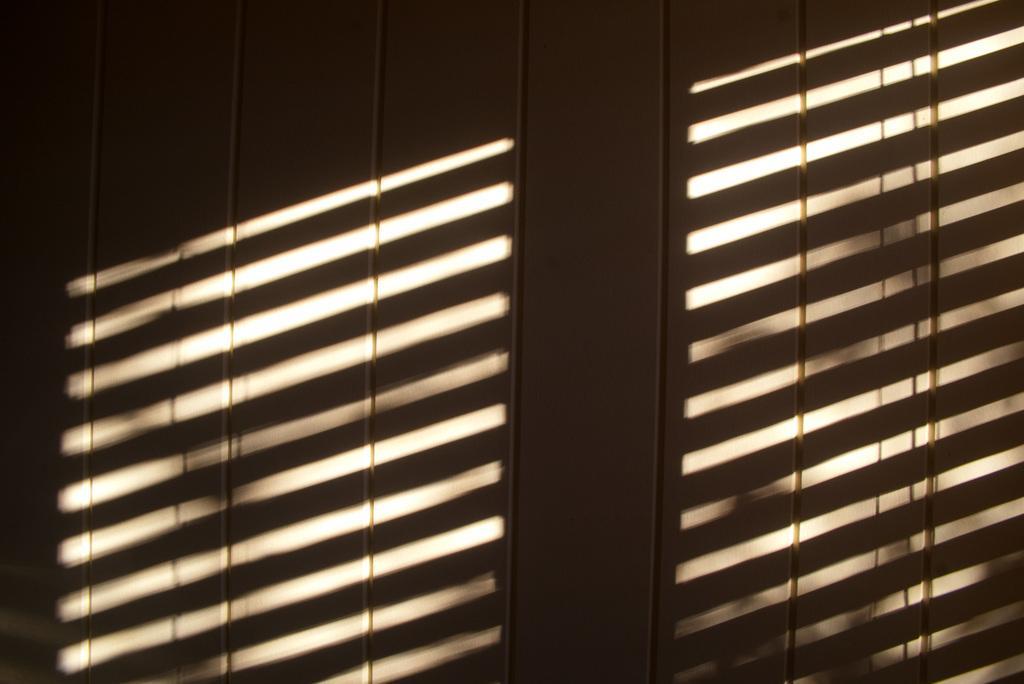Could you give a brief overview of what you see in this image? In this image, we can see some shadows on the wall. 